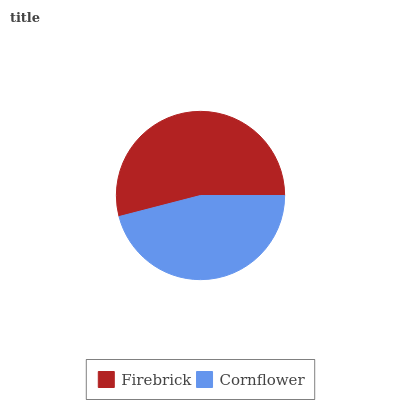Is Cornflower the minimum?
Answer yes or no. Yes. Is Firebrick the maximum?
Answer yes or no. Yes. Is Cornflower the maximum?
Answer yes or no. No. Is Firebrick greater than Cornflower?
Answer yes or no. Yes. Is Cornflower less than Firebrick?
Answer yes or no. Yes. Is Cornflower greater than Firebrick?
Answer yes or no. No. Is Firebrick less than Cornflower?
Answer yes or no. No. Is Firebrick the high median?
Answer yes or no. Yes. Is Cornflower the low median?
Answer yes or no. Yes. Is Cornflower the high median?
Answer yes or no. No. Is Firebrick the low median?
Answer yes or no. No. 